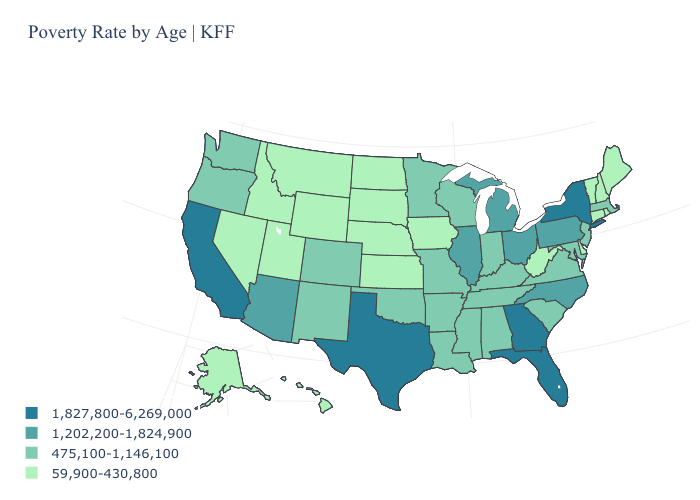Does the first symbol in the legend represent the smallest category?
Concise answer only. No. What is the value of Florida?
Give a very brief answer. 1,827,800-6,269,000. What is the highest value in the USA?
Be succinct. 1,827,800-6,269,000. What is the lowest value in the West?
Quick response, please. 59,900-430,800. How many symbols are there in the legend?
Keep it brief. 4. What is the highest value in the West ?
Write a very short answer. 1,827,800-6,269,000. Does Georgia have a lower value than Florida?
Be succinct. No. What is the value of Wyoming?
Give a very brief answer. 59,900-430,800. Is the legend a continuous bar?
Give a very brief answer. No. Does Tennessee have the highest value in the South?
Keep it brief. No. What is the lowest value in the South?
Answer briefly. 59,900-430,800. What is the lowest value in states that border North Dakota?
Answer briefly. 59,900-430,800. Is the legend a continuous bar?
Answer briefly. No. What is the lowest value in the Northeast?
Write a very short answer. 59,900-430,800. Among the states that border Colorado , which have the lowest value?
Give a very brief answer. Kansas, Nebraska, Utah, Wyoming. 